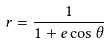Convert formula to latex. <formula><loc_0><loc_0><loc_500><loc_500>r = \frac { 1 } { 1 + e \cos \theta }</formula> 